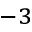Convert formula to latex. <formula><loc_0><loc_0><loc_500><loc_500>^ { - 3 }</formula> 